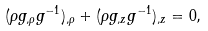<formula> <loc_0><loc_0><loc_500><loc_500>( \rho g _ { , \rho } g ^ { - 1 } ) _ { , \rho } + ( \rho g _ { , z } g ^ { - 1 } ) _ { , z } = 0 ,</formula> 